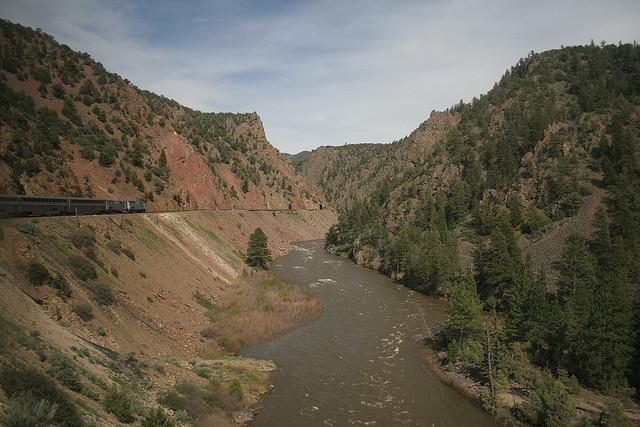Is this a dangerous road?
Keep it brief. Yes. Is this a vacation spot?
Be succinct. No. Is the train moving?
Keep it brief. Yes. Is it cloudy outdoors?
Answer briefly. Yes. What side of the train the a cliff?
Be succinct. Left. What is on the side walls of the canyon?
Quick response, please. Trees. What liquid is moving in the valley?
Be succinct. Water. Is there a card game that sounds like an item in this photo?
Quick response, please. No. Is the train going through a tunnel?
Short answer required. No. Is anyone in the water?
Short answer required. No. Can the train fall down?
Be succinct. Yes. 